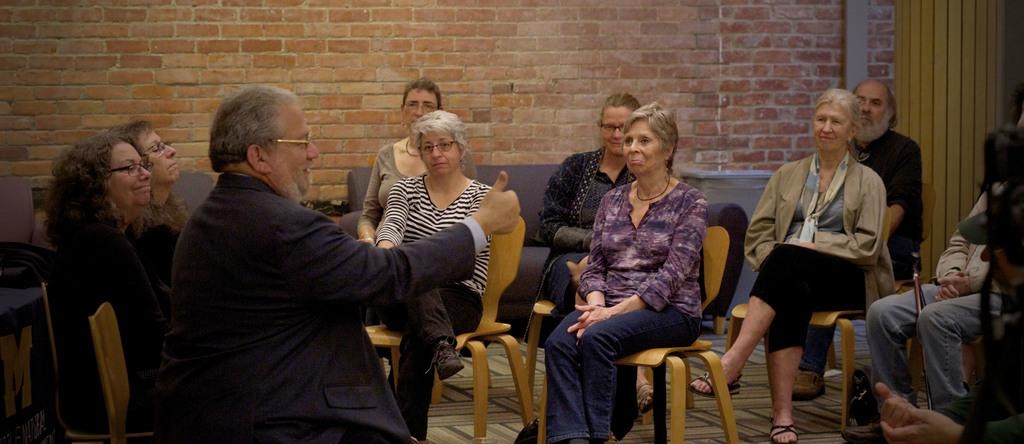What is happening in the image? There is a group of people in the image, and they are sitting on chairs. Can you describe the setting in the image? There is a couch in the background of the image, and there is also a wall visible in the background. What type of cherry is being used to connect the appliances in the image? There is no cherry or appliance present in the image; it features a group of people sitting on chairs with a couch and a wall in the background. 